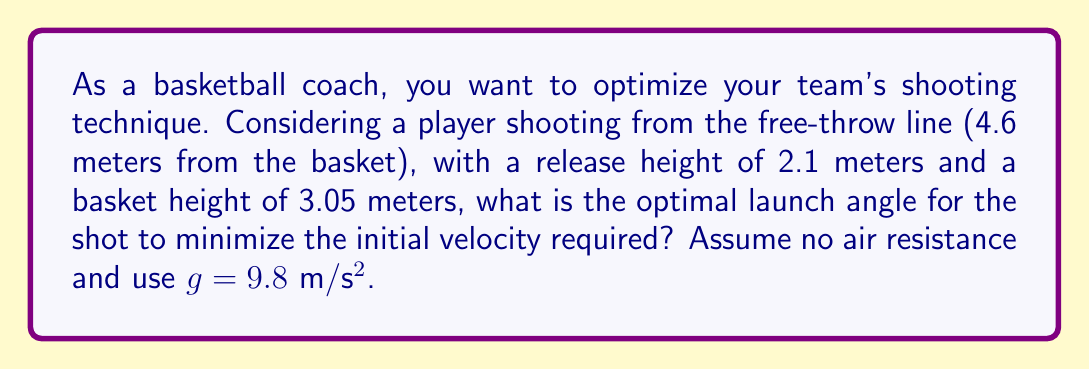Teach me how to tackle this problem. Let's approach this step-by-step using projectile motion equations:

1) First, we need to set up our coordinate system. Let x be the horizontal distance and y be the vertical distance.

2) The equations of motion for projectile motion are:
   $$x = v_0 \cos(\theta) t$$
   $$y = 2.1 + v_0 \sin(\theta) t - \frac{1}{2}gt^2$$

3) We know that when the ball reaches the basket:
   x = 4.6 m
   y = 3.05 m
   
4) Substituting these into our equations:
   $$4.6 = v_0 \cos(\theta) t$$
   $$3.05 = 2.1 + v_0 \sin(\theta) t - 4.9t^2$$

5) From the first equation:
   $$t = \frac{4.6}{v_0 \cos(\theta)}$$

6) Substituting this into the second equation:
   $$3.05 = 2.1 + v_0 \sin(\theta) \frac{4.6}{v_0 \cos(\theta)} - 4.9(\frac{4.6}{v_0 \cos(\theta)})^2$$

7) Simplifying:
   $$0.95 = 4.6 \tan(\theta) - \frac{103.78}{v_0^2 \cos^2(\theta)}$$

8) To minimize $v_0$, we need to maximize $\cos^2(\theta)$. This occurs when:
   $$\tan(\theta) = \frac{4.6}{2(3.05-2.1)} = 1.917$$

9) Therefore, the optimal angle is:
   $$\theta = \arctan(1.917) = 62.4°$$

This angle minimizes the initial velocity required for the shot.
Answer: 62.4° 